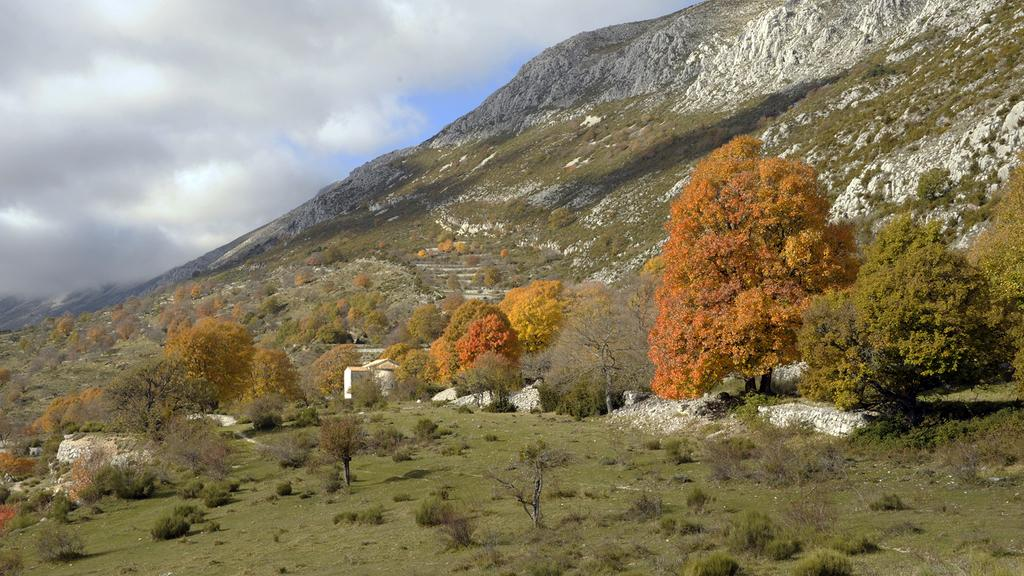What type of structure is shown in the image? The image appears to depict a house. What can be seen on the right side of the image? There are trees and a hill on the right side of the image. What is visible at the top of the image? The sky is visible at the top of the image. How many daughters are present in the image? There is no mention of a daughter or any people in the image; it depicts a house, trees, a hill, and the sky. 